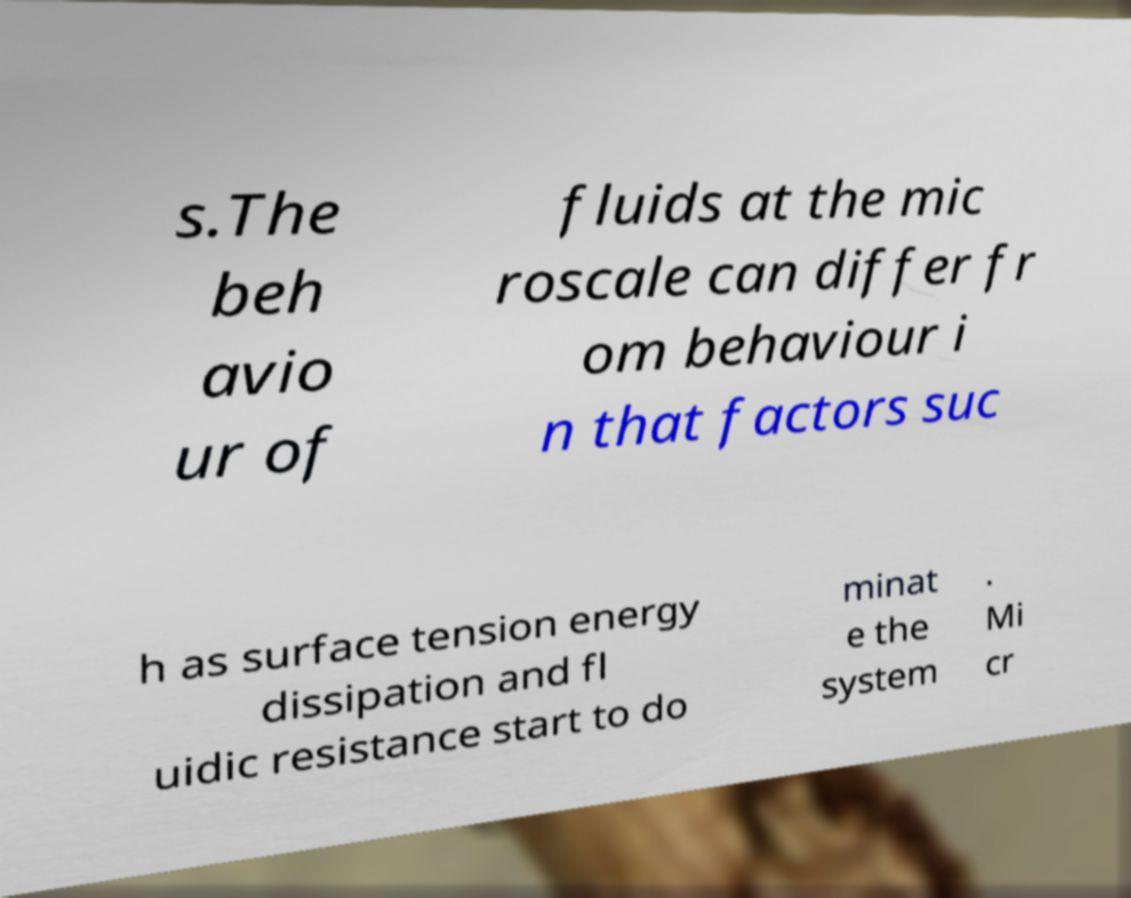Could you extract and type out the text from this image? s.The beh avio ur of fluids at the mic roscale can differ fr om behaviour i n that factors suc h as surface tension energy dissipation and fl uidic resistance start to do minat e the system . Mi cr 